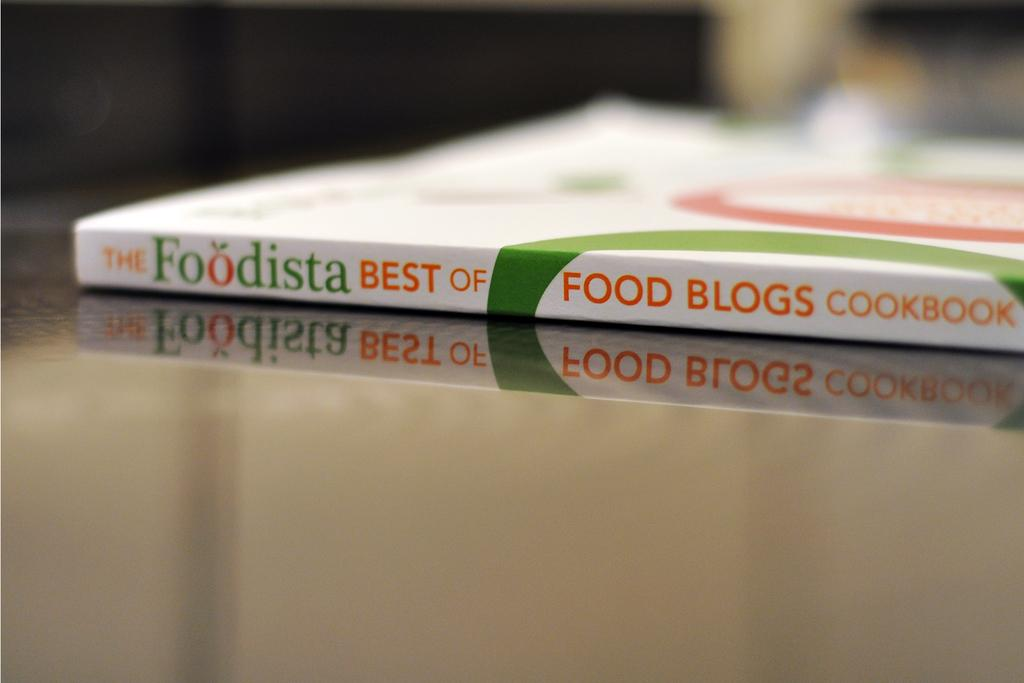<image>
Offer a succinct explanation of the picture presented. A cookbook of the best food blogs  is on a table. 